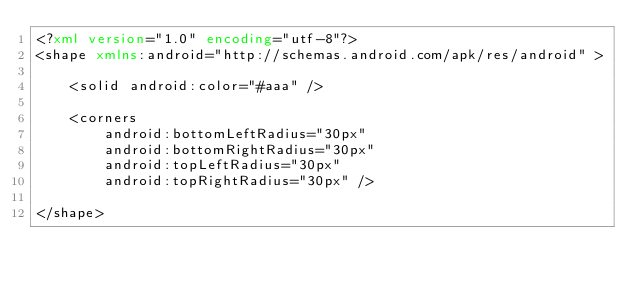<code> <loc_0><loc_0><loc_500><loc_500><_XML_><?xml version="1.0" encoding="utf-8"?>
<shape xmlns:android="http://schemas.android.com/apk/res/android" >

    <solid android:color="#aaa" />

    <corners
        android:bottomLeftRadius="30px"
        android:bottomRightRadius="30px"
        android:topLeftRadius="30px"
        android:topRightRadius="30px" />

</shape></code> 